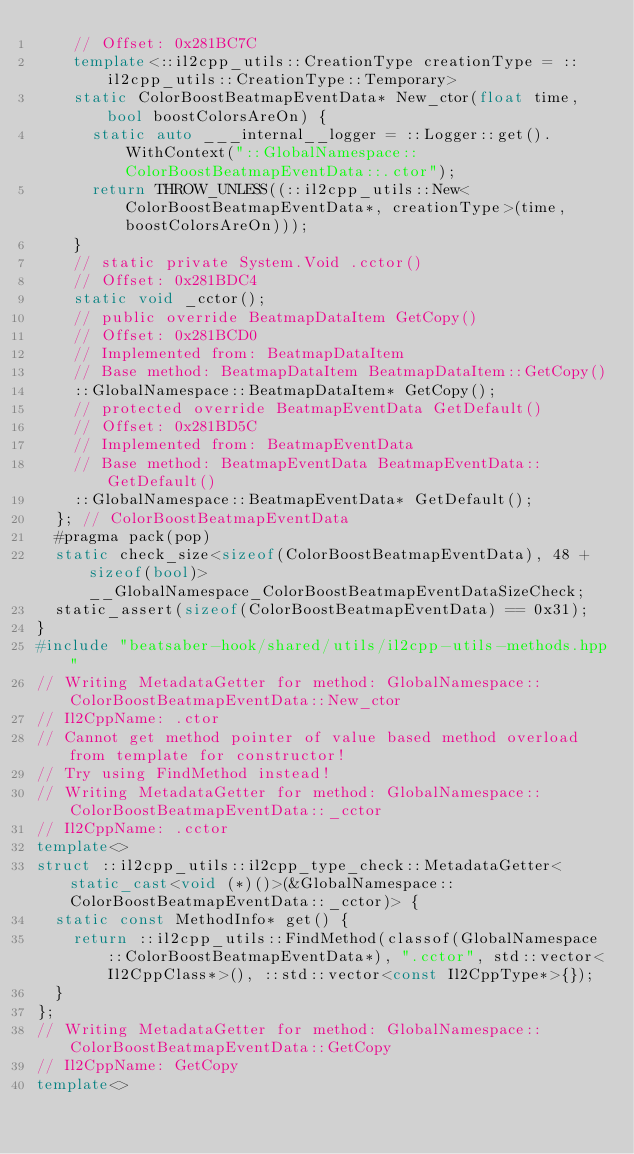Convert code to text. <code><loc_0><loc_0><loc_500><loc_500><_C++_>    // Offset: 0x281BC7C
    template<::il2cpp_utils::CreationType creationType = ::il2cpp_utils::CreationType::Temporary>
    static ColorBoostBeatmapEventData* New_ctor(float time, bool boostColorsAreOn) {
      static auto ___internal__logger = ::Logger::get().WithContext("::GlobalNamespace::ColorBoostBeatmapEventData::.ctor");
      return THROW_UNLESS((::il2cpp_utils::New<ColorBoostBeatmapEventData*, creationType>(time, boostColorsAreOn)));
    }
    // static private System.Void .cctor()
    // Offset: 0x281BDC4
    static void _cctor();
    // public override BeatmapDataItem GetCopy()
    // Offset: 0x281BCD0
    // Implemented from: BeatmapDataItem
    // Base method: BeatmapDataItem BeatmapDataItem::GetCopy()
    ::GlobalNamespace::BeatmapDataItem* GetCopy();
    // protected override BeatmapEventData GetDefault()
    // Offset: 0x281BD5C
    // Implemented from: BeatmapEventData
    // Base method: BeatmapEventData BeatmapEventData::GetDefault()
    ::GlobalNamespace::BeatmapEventData* GetDefault();
  }; // ColorBoostBeatmapEventData
  #pragma pack(pop)
  static check_size<sizeof(ColorBoostBeatmapEventData), 48 + sizeof(bool)> __GlobalNamespace_ColorBoostBeatmapEventDataSizeCheck;
  static_assert(sizeof(ColorBoostBeatmapEventData) == 0x31);
}
#include "beatsaber-hook/shared/utils/il2cpp-utils-methods.hpp"
// Writing MetadataGetter for method: GlobalNamespace::ColorBoostBeatmapEventData::New_ctor
// Il2CppName: .ctor
// Cannot get method pointer of value based method overload from template for constructor!
// Try using FindMethod instead!
// Writing MetadataGetter for method: GlobalNamespace::ColorBoostBeatmapEventData::_cctor
// Il2CppName: .cctor
template<>
struct ::il2cpp_utils::il2cpp_type_check::MetadataGetter<static_cast<void (*)()>(&GlobalNamespace::ColorBoostBeatmapEventData::_cctor)> {
  static const MethodInfo* get() {
    return ::il2cpp_utils::FindMethod(classof(GlobalNamespace::ColorBoostBeatmapEventData*), ".cctor", std::vector<Il2CppClass*>(), ::std::vector<const Il2CppType*>{});
  }
};
// Writing MetadataGetter for method: GlobalNamespace::ColorBoostBeatmapEventData::GetCopy
// Il2CppName: GetCopy
template<></code> 